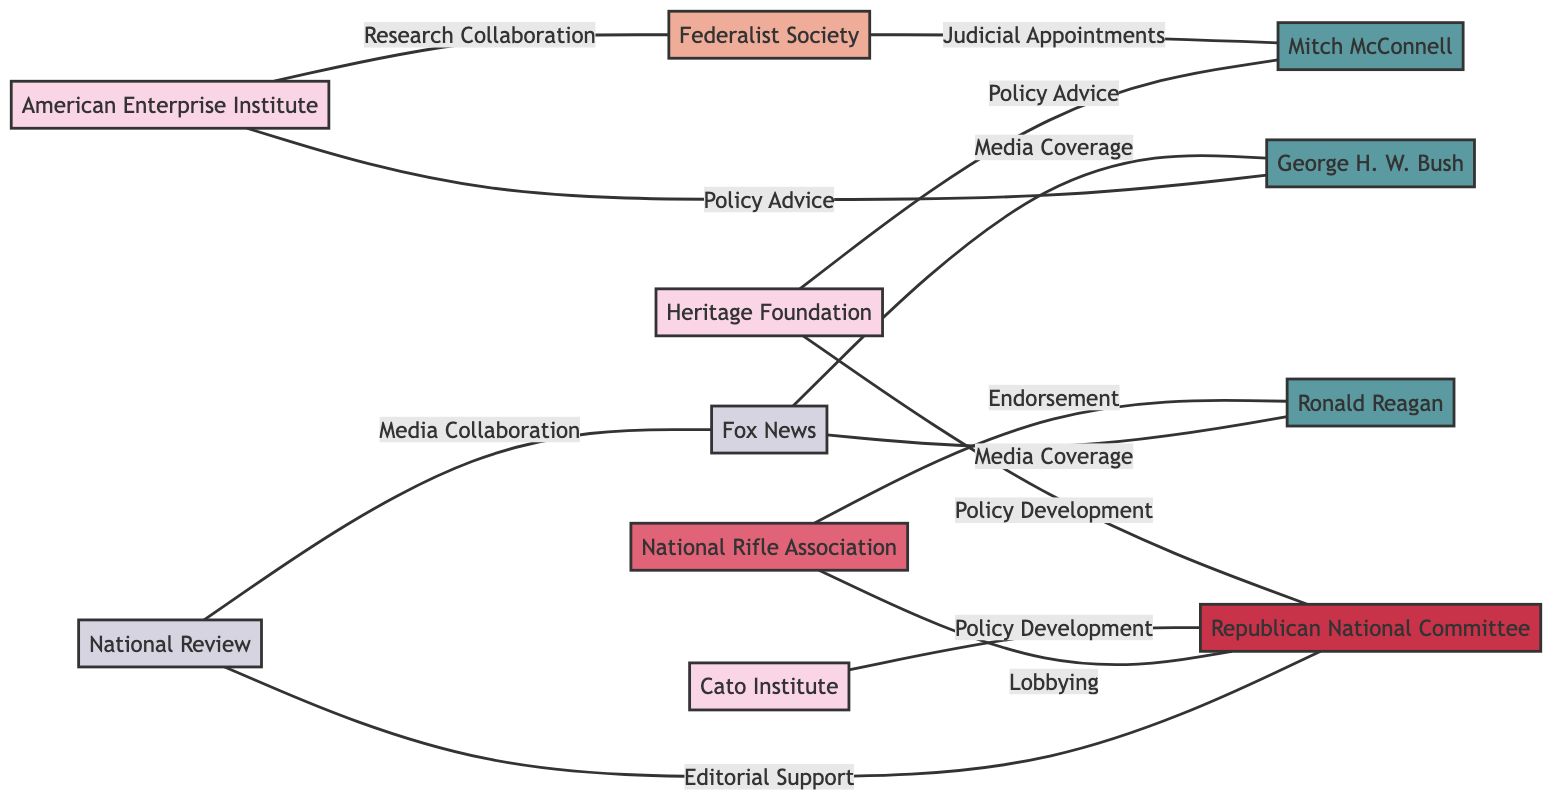What is the total number of nodes in the graph? The graph lists 11 distinct entities categorized into different types such as Think Tanks, Politicians, a Political Party, Advocacy Group, and Media Outlets. Counting these gives us a total of 11 nodes.
Answer: 11 Which organization has a relationship of 'Policy Development' with the Republican National Committee? The diagram shows two edges labeled 'Policy Development' connecting the Heritage Foundation and the Cato Institute to the Republican National Committee.
Answer: Heritage Foundation, Cato Institute Who endorsed Ronald Reagan? The National Rifle Association is directly connected to Ronald Reagan through the 'Endorsement' relationship in the diagram.
Answer: National Rifle Association How many edges connect to Mitch McConnell? The diagram indicates that Mitch McConnell is connected by three edges: one for 'Judicial Appointments' from the Federalist Society, one for 'Policy Advice' from the Heritage Foundation, and one for 'Research Collaboration' with the American Enterprise Institute. Counting these edges gives a total of 2 connections.
Answer: 2 What type of organization is the Cato Institute? Based on the node class definitions in the diagram, the Cato Institute is categorized as a 'Think Tank'.
Answer: Think Tank Which media outlet collaborated with National Review? The diagram highlights a relationship of 'Media Collaboration' between National Review and Fox News, indicating that Fox News is the media outlet involved.
Answer: Fox News Name one politician advised by the Heritage Foundation. The diagram shows an edge labeled 'Policy Advice' connecting the Heritage Foundation to Mitch McConnell, indicating that Mitch McConnell is advised by the Heritage Foundation.
Answer: Mitch McConnell How many unique organizations are related to the Republican National Committee? The diagram illustrates three unique organizations linked to the Republican National Committee: the Heritage Foundation, Cato Institute, and National Rifle Association. Thus, the total number of unique organizations related to it is 4.
Answer: 4 Which type of organization is the Federalist Society? The Federalist Society is identified under the 'Legal Organization' category as per the node types provided in the diagram.
Answer: Legal Organization 